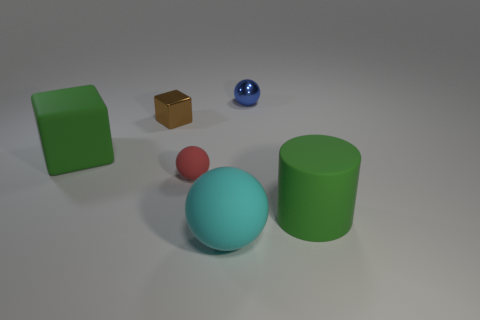Add 4 brown metal spheres. How many objects exist? 10 Subtract all cubes. How many objects are left? 4 Subtract 0 yellow cubes. How many objects are left? 6 Subtract all brown things. Subtract all small brown objects. How many objects are left? 4 Add 1 big green cylinders. How many big green cylinders are left? 2 Add 1 tiny red spheres. How many tiny red spheres exist? 2 